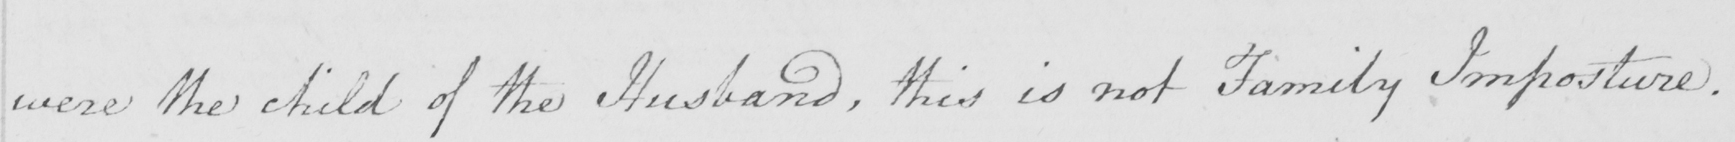Please provide the text content of this handwritten line. were the child of the Husband , this is not Family Imposture . 